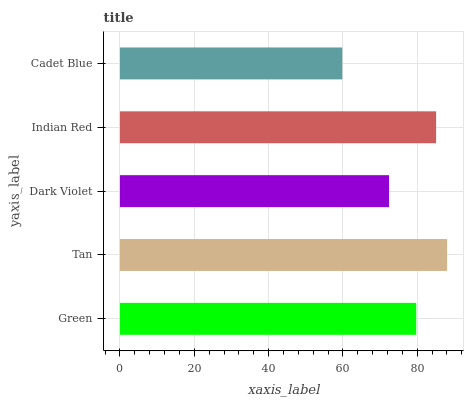Is Cadet Blue the minimum?
Answer yes or no. Yes. Is Tan the maximum?
Answer yes or no. Yes. Is Dark Violet the minimum?
Answer yes or no. No. Is Dark Violet the maximum?
Answer yes or no. No. Is Tan greater than Dark Violet?
Answer yes or no. Yes. Is Dark Violet less than Tan?
Answer yes or no. Yes. Is Dark Violet greater than Tan?
Answer yes or no. No. Is Tan less than Dark Violet?
Answer yes or no. No. Is Green the high median?
Answer yes or no. Yes. Is Green the low median?
Answer yes or no. Yes. Is Cadet Blue the high median?
Answer yes or no. No. Is Cadet Blue the low median?
Answer yes or no. No. 